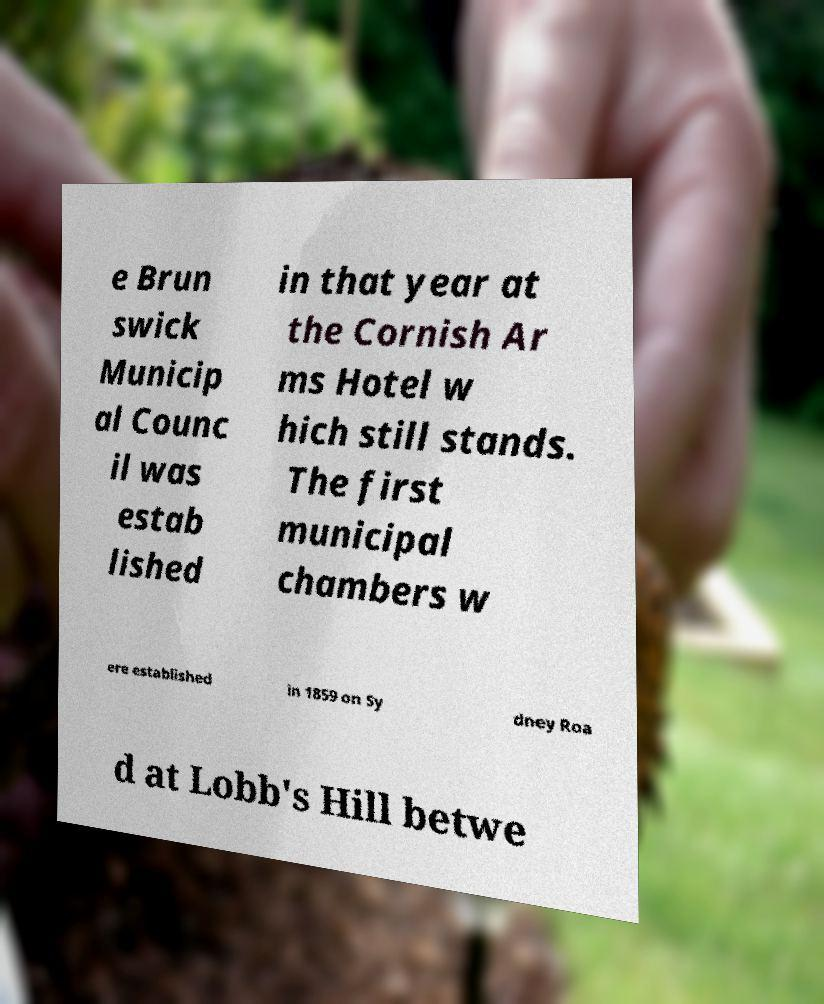Could you assist in decoding the text presented in this image and type it out clearly? e Brun swick Municip al Counc il was estab lished in that year at the Cornish Ar ms Hotel w hich still stands. The first municipal chambers w ere established in 1859 on Sy dney Roa d at Lobb's Hill betwe 